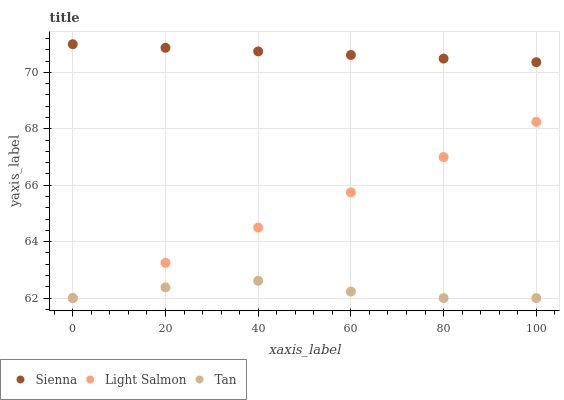Does Tan have the minimum area under the curve?
Answer yes or no. Yes. Does Sienna have the maximum area under the curve?
Answer yes or no. Yes. Does Light Salmon have the minimum area under the curve?
Answer yes or no. No. Does Light Salmon have the maximum area under the curve?
Answer yes or no. No. Is Light Salmon the smoothest?
Answer yes or no. Yes. Is Tan the roughest?
Answer yes or no. Yes. Is Tan the smoothest?
Answer yes or no. No. Is Light Salmon the roughest?
Answer yes or no. No. Does Light Salmon have the lowest value?
Answer yes or no. Yes. Does Sienna have the highest value?
Answer yes or no. Yes. Does Light Salmon have the highest value?
Answer yes or no. No. Is Tan less than Sienna?
Answer yes or no. Yes. Is Sienna greater than Light Salmon?
Answer yes or no. Yes. Does Light Salmon intersect Tan?
Answer yes or no. Yes. Is Light Salmon less than Tan?
Answer yes or no. No. Is Light Salmon greater than Tan?
Answer yes or no. No. Does Tan intersect Sienna?
Answer yes or no. No. 